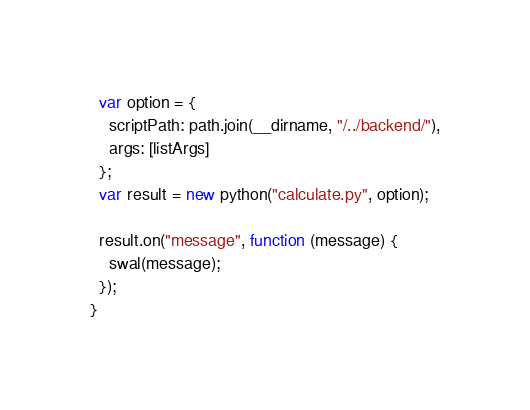Convert code to text. <code><loc_0><loc_0><loc_500><loc_500><_JavaScript_>  var option = {
    scriptPath: path.join(__dirname, "/../backend/"),
    args: [listArgs]
  };
  var result = new python("calculate.py", option);

  result.on("message", function (message) {
    swal(message);
  });
}
</code> 